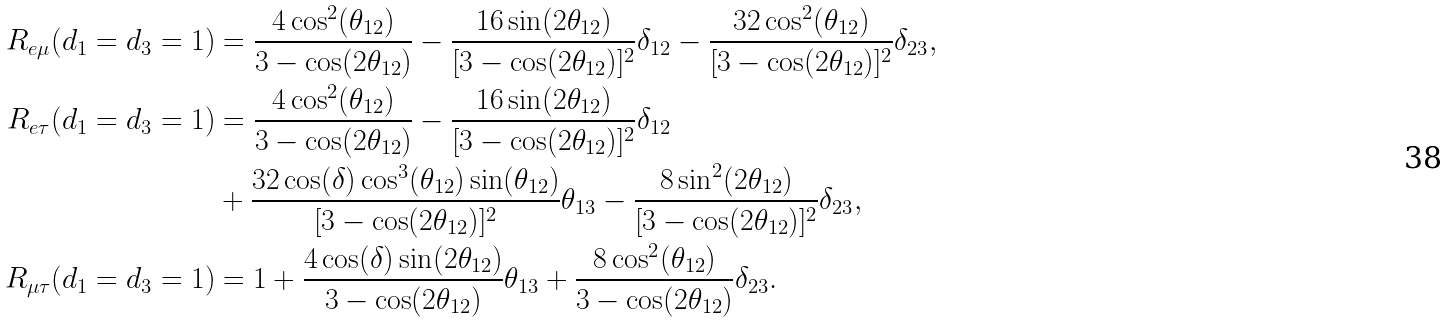<formula> <loc_0><loc_0><loc_500><loc_500>R _ { e \mu } ( d _ { 1 } = d _ { 3 } = 1 ) & = \frac { 4 \cos ^ { 2 } ( \theta _ { 1 2 } ) } { 3 - \cos ( 2 \theta _ { 1 2 } ) } - \frac { 1 6 \sin ( 2 \theta _ { 1 2 } ) } { [ 3 - \cos ( 2 \theta _ { 1 2 } ) ] ^ { 2 } } \delta _ { 1 2 } - \frac { 3 2 \cos ^ { 2 } ( \theta _ { 1 2 } ) } { [ 3 - \cos ( 2 \theta _ { 1 2 } ) ] ^ { 2 } } \delta _ { 2 3 } , \\ R _ { e \tau } ( d _ { 1 } = d _ { 3 } = 1 ) & = \frac { 4 \cos ^ { 2 } ( \theta _ { 1 2 } ) } { 3 - \cos ( 2 \theta _ { 1 2 } ) } - \frac { 1 6 \sin ( 2 \theta _ { 1 2 } ) } { [ 3 - \cos ( 2 \theta _ { 1 2 } ) ] ^ { 2 } } \delta _ { 1 2 } \\ & + \frac { 3 2 \cos ( \delta ) \cos ^ { 3 } ( \theta _ { 1 2 } ) \sin ( \theta _ { 1 2 } ) } { [ 3 - \cos ( 2 \theta _ { 1 2 } ) ] ^ { 2 } } \theta _ { 1 3 } - \frac { 8 \sin ^ { 2 } ( 2 \theta _ { 1 2 } ) } { [ 3 - \cos ( 2 \theta _ { 1 2 } ) ] ^ { 2 } } \delta _ { 2 3 } , \\ R _ { \mu \tau } ( d _ { 1 } = d _ { 3 } = 1 ) & = 1 + \frac { 4 \cos ( \delta ) \sin ( 2 \theta _ { 1 2 } ) } { 3 - \cos ( 2 \theta _ { 1 2 } ) } \theta _ { 1 3 } + \frac { 8 \cos ^ { 2 } ( \theta _ { 1 2 } ) } { 3 - \cos ( 2 \theta _ { 1 2 } ) } \delta _ { 2 3 } .</formula> 